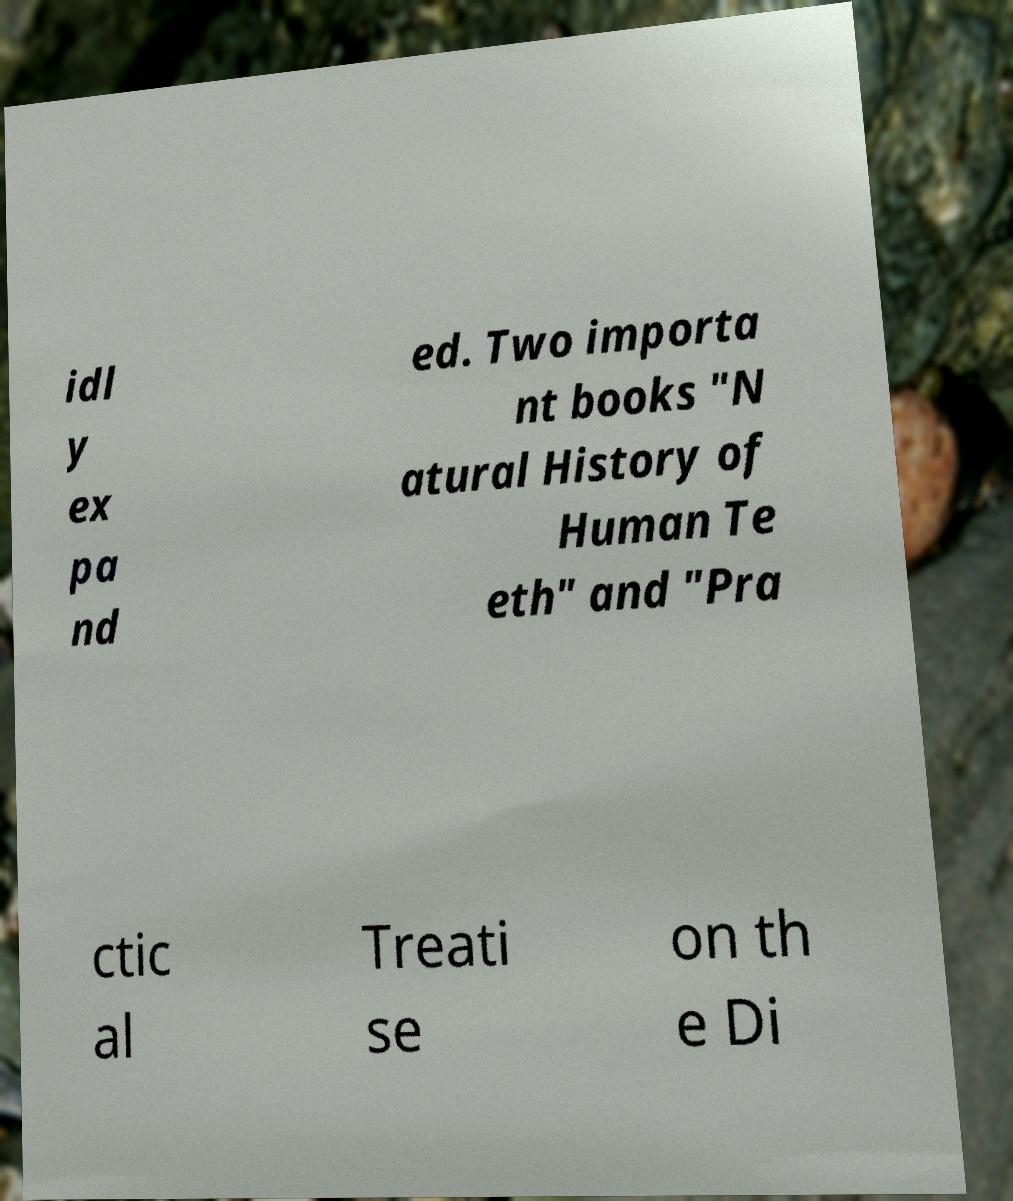Can you accurately transcribe the text from the provided image for me? idl y ex pa nd ed. Two importa nt books "N atural History of Human Te eth" and "Pra ctic al Treati se on th e Di 